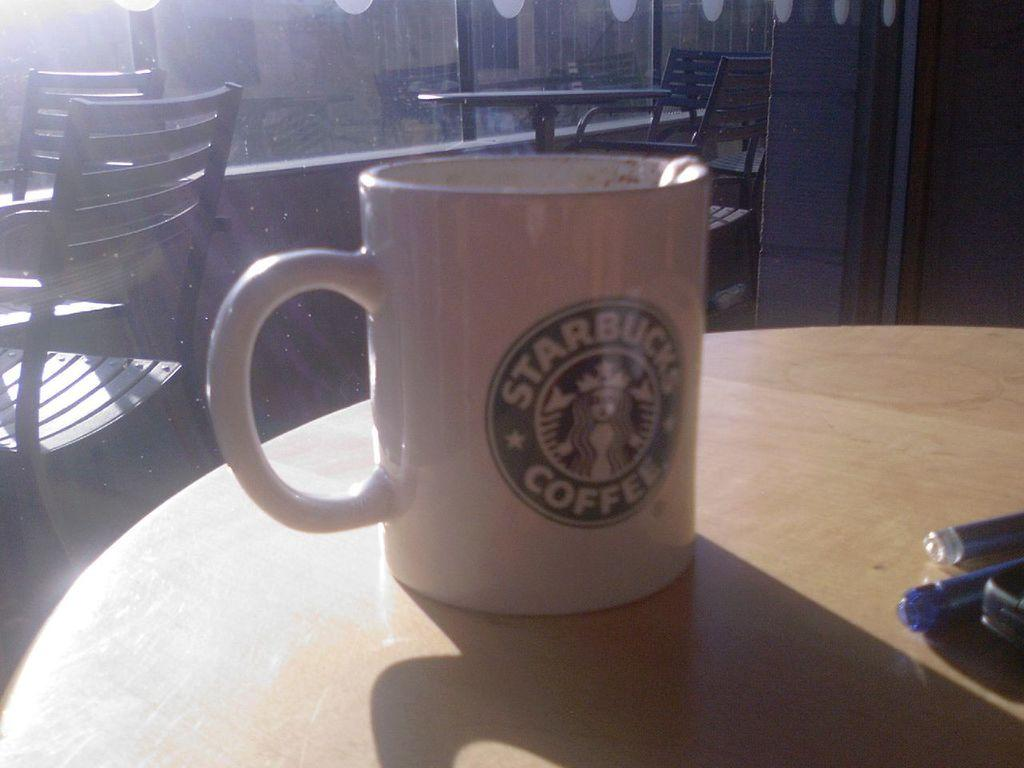<image>
Describe the image concisely. A white starbucks coffee mug sits on a wooden table in the sunlight. 